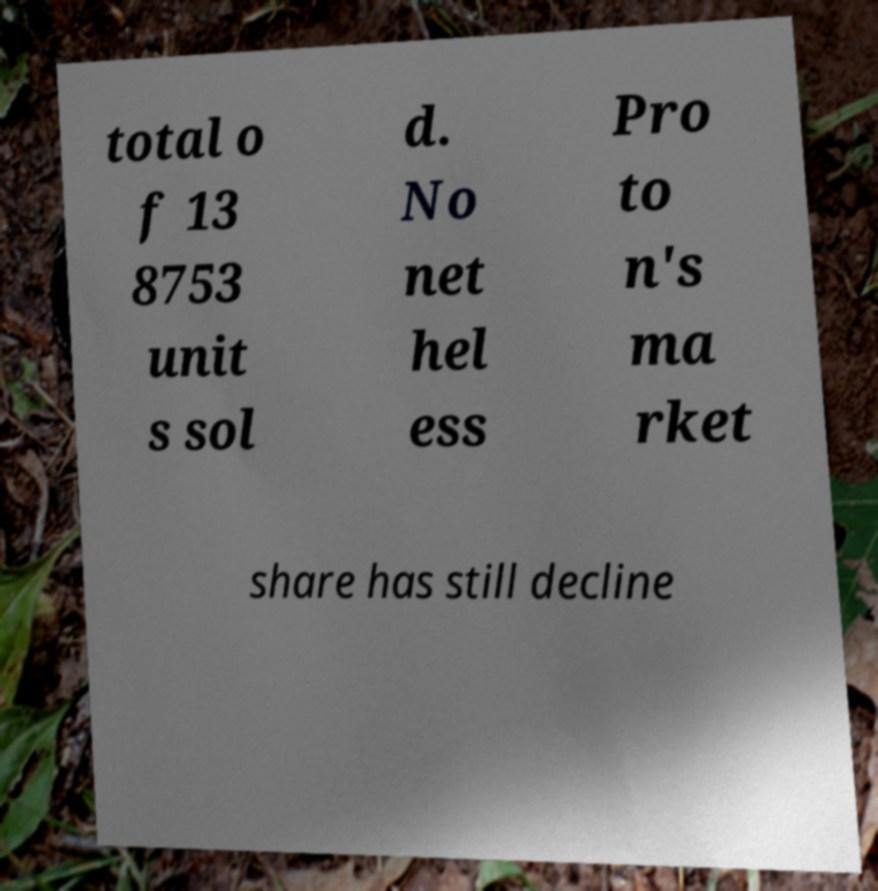What messages or text are displayed in this image? I need them in a readable, typed format. total o f 13 8753 unit s sol d. No net hel ess Pro to n's ma rket share has still decline 